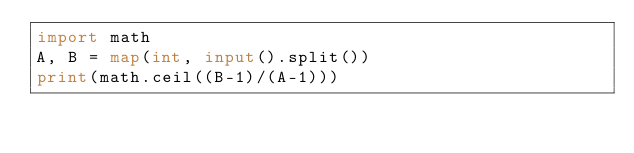<code> <loc_0><loc_0><loc_500><loc_500><_Python_>import math
A, B = map(int, input().split())
print(math.ceil((B-1)/(A-1)))
</code> 